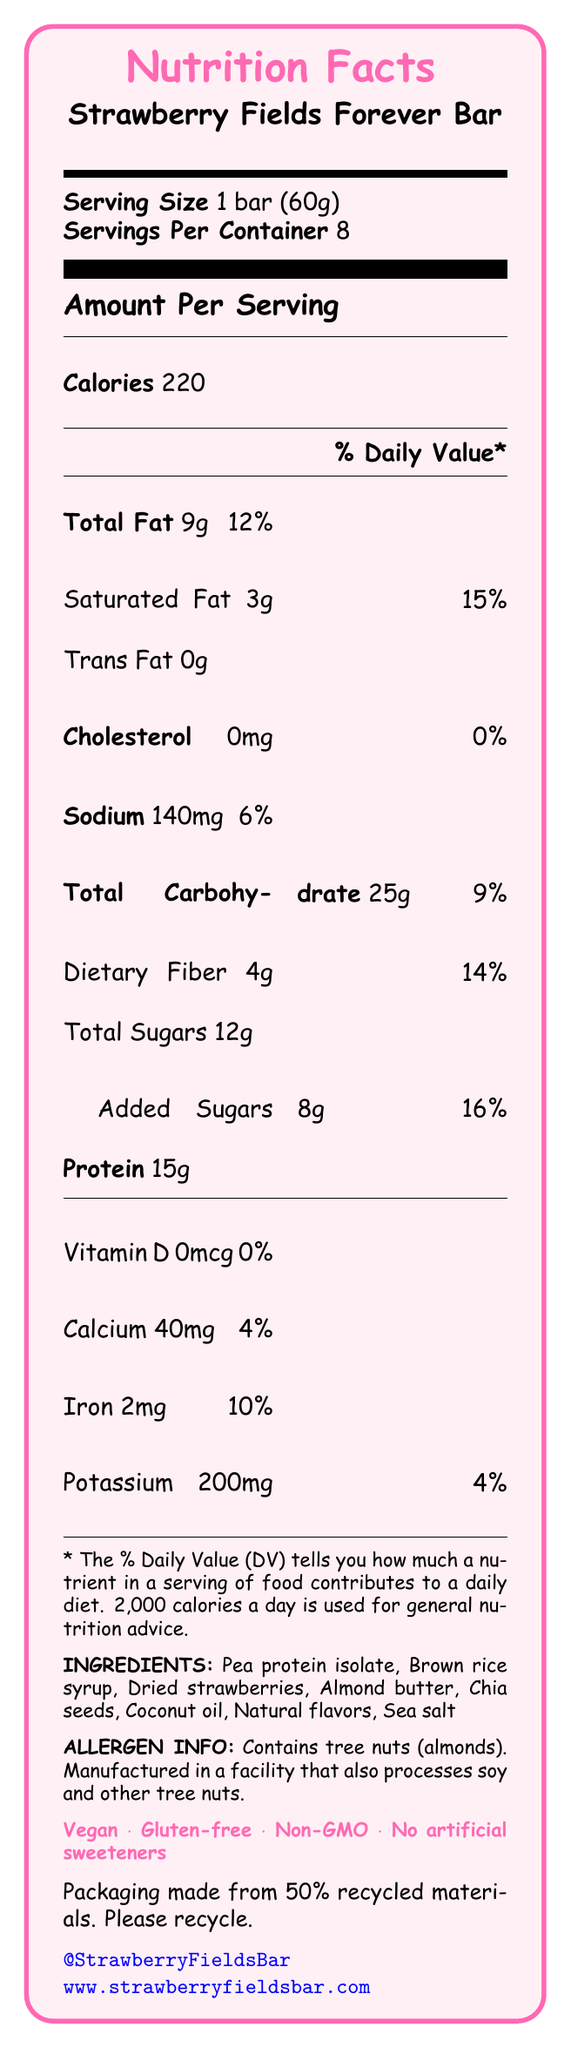what is the serving size of the "Strawberry Fields Forever Bar"? The serving size is listed clearly in the Nutrition Facts section under the product name.
Answer: 1 bar (60g) how many servings are there per container? The document states that there are 8 servings per container.
Answer: 8 how much protein does one serving provide? The amount of protein per serving is listed under the Amount Per Serving section.
Answer: 15g what is the total fat content for one serving, and what percentage of daily value does it contribute? The total fat listed in the document is 9g, which contributes to 12% of the daily value.
Answer: 9g, 12% what allergens does the document mention? The document's allergen information states the bar contains tree nuts (almonds).
Answer: Tree nuts (almonds) how much iron is in one serving? The amount of iron is listed as 2mg in the Amount Per Serving section.
Answer: 2mg what percent daily value of saturated fat is in one serving? The document lists the saturated fat as 3g, which is 15% of the daily value.
Answer: 15% does the bar contain any cholesterol? The document lists cholesterol as 0mg, indicating that the bar contains no cholesterol.
Answer: No is the "Strawberry Fields Forever Bar" vegan? The document claims that the bar is vegan.
Answer: Yes list three ingredients found in the bar. These ingredients are listed under the INGREDIENTS section.
Answer: Pea protein isolate, Brown rice syrup, Dried strawberries what is the main theme or flavor of this protein bar? The document mentions that the bar is inspired by the Beatles' song "Strawberry Fields Forever".
Answer: Strawberry Fields Forever flavor how much dietary fiber does one serving contain? The amount of dietary fiber in one serving is listed as 4g.
Answer: 4g does the protein bar contain any artificial sweeteners? The document states that the bar has no artificial sweeteners.
Answer: No D. Non-GMO The document mentions the claims as vegan, gluten-free, and non-GMO, but not organic.
Answer: A how much sodium does one serving contain and its daily value percentage? The document lists sodium content as 140mg and the daily value percentage as 6%.
Answer: 140mg, 6% IV. Strawberry Fields Forever The document references "Help!" in the protein claim as "Help! It's high in protein".
Answer: I. Help! Is the packaging of the bar made from recycled materials? The sustainability note states that the packaging is made from 50% recycled materials.
Answer: Yes why might someone not be able to consume this protein bar? The allergen info mentions the bar contains tree nuts (almonds) which may not be suitable for those with tree nut allergies.
Answer: Allergic to tree nuts what percentage of daily value for added sugars does this bar contribute? The document lists added sugars as 8g, which is 16% of the daily value.
Answer: 16% summarize the main features of the "Strawberry Fields Forever Bar" enforced by the Beatles theme. The document provides comprehensive nutritional information, highlights its allergen contents, and mentions Beatles-inspired elements for thematic appeal.
Answer: The "Strawberry Fields Forever Bar" is a vegan, gluten-free protein bar inspired by Beatles songs. It weighs 60g per serving with 15g of protein, 9g of total fat, and 12g of sugar. Claims include non-GMO and no artificial sweeteners, with packaging made from 50% recycled materials. Beatles references include the Strawberry Fields Forever flavor, Yellow Submarine shape, high protein as "Help!", and nutritional needs as "All You Need Is Love." what is the exact social media handle for the bar? The social media handle is listed at the end of the document in blue text.
Answer: @StrawberryFieldsBar are there any details about the manufacturer's location? The document does not provide details about the manufacturer's location.
Answer: Not enough information 